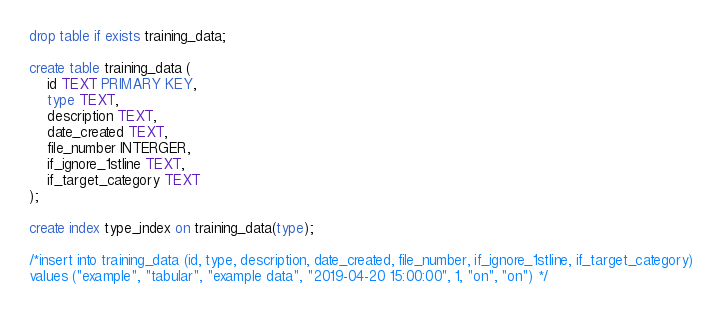<code> <loc_0><loc_0><loc_500><loc_500><_SQL_>drop table if exists training_data;

create table training_data (
    id TEXT PRIMARY KEY,
    type TEXT, 
    description TEXT,
    date_created TEXT,
    file_number INTERGER,
    if_ignore_1stline TEXT,
    if_target_category TEXT 
);

create index type_index on training_data(type);

/*insert into training_data (id, type, description, date_created, file_number, if_ignore_1stline, if_target_category)
values ("example", "tabular", "example data", "2019-04-20 15:00:00", 1, "on", "on") */

</code> 